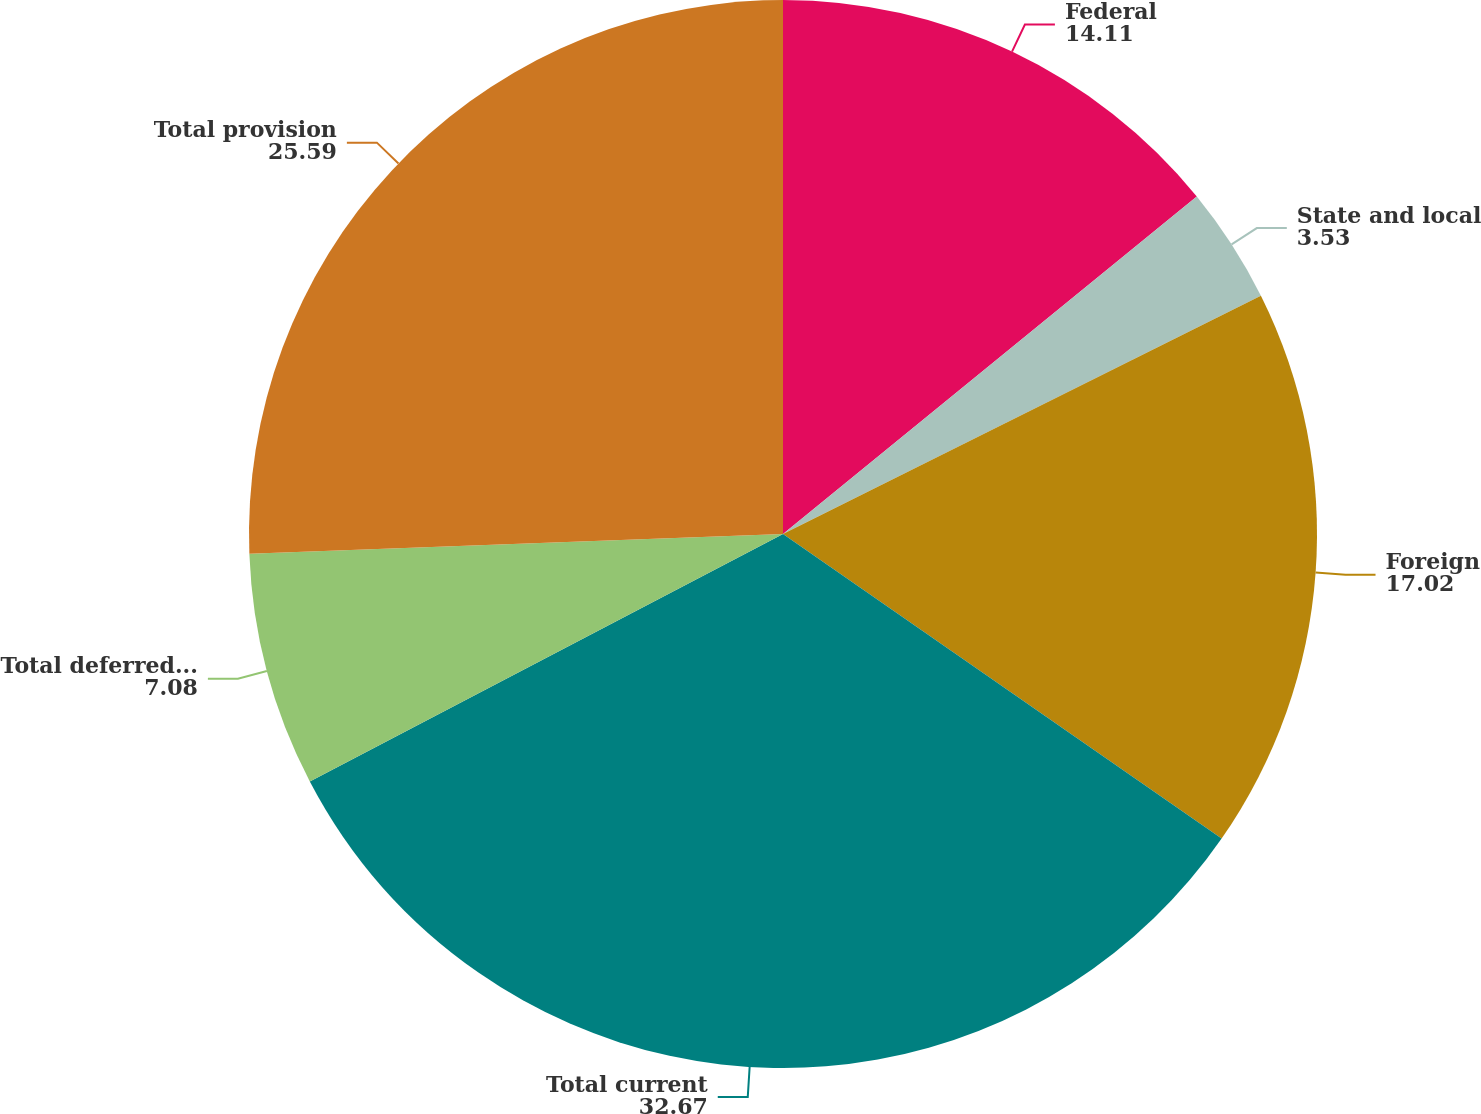Convert chart. <chart><loc_0><loc_0><loc_500><loc_500><pie_chart><fcel>Federal<fcel>State and local<fcel>Foreign<fcel>Total current<fcel>Total deferred tax benefit<fcel>Total provision<nl><fcel>14.11%<fcel>3.53%<fcel>17.02%<fcel>32.67%<fcel>7.08%<fcel>25.59%<nl></chart> 